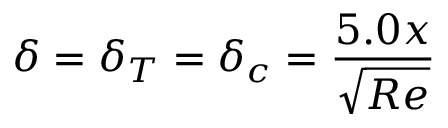Convert formula to latex. <formula><loc_0><loc_0><loc_500><loc_500>\delta = \delta _ { T } = \delta _ { c } = { \frac { 5 . 0 x } { \sqrt { R e } } }</formula> 